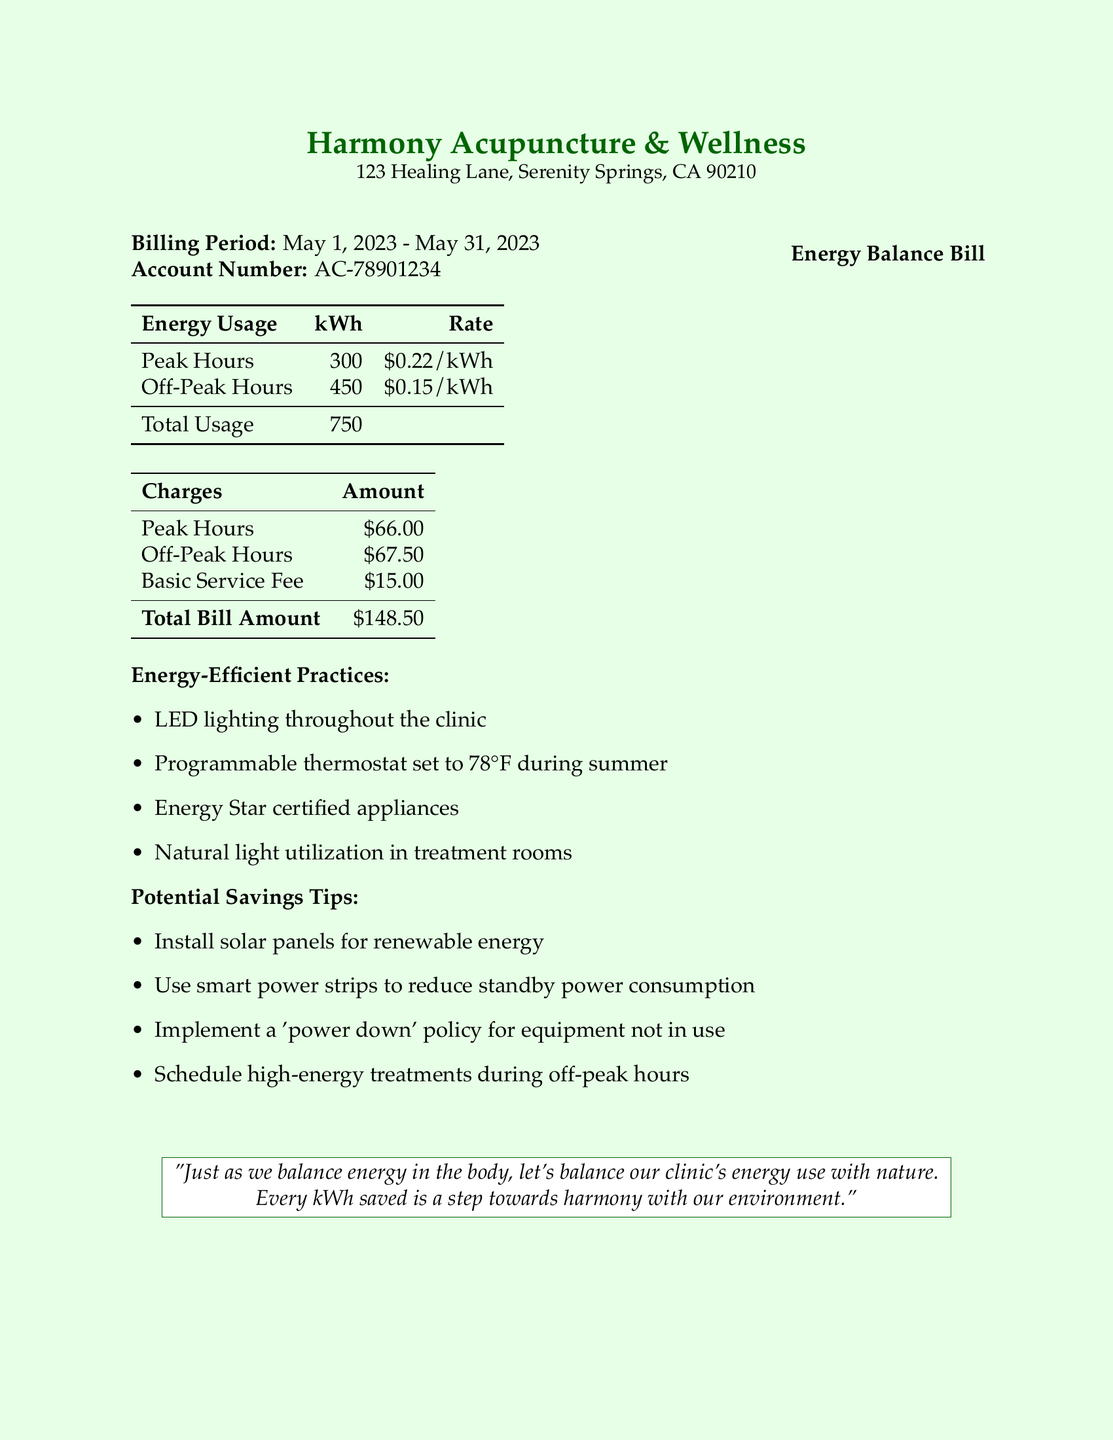What is the billing period? The billing period is specified in the document as the time frame for which the electricity usage is being billed.
Answer: May 1, 2023 - May 31, 2023 What is the total energy usage? The total energy usage is the sum of the peak and off-peak hour usage provided in the table.
Answer: 750 kWh How much was charged for peak hours? The amount charged for peak hours is listed in the charges table.
Answer: $66.00 What is the total bill amount? The total bill amount is calculated by adding all the charges listed in the document.
Answer: $148.50 What energy-efficient practice is mentioned regarding lighting? The document specifies an energy-efficient practice related to lighting used in the clinic.
Answer: LED lighting throughout the clinic What potential savings tip involves renewable energy? Among the potential savings tips, one specifically suggests using a renewable energy source.
Answer: Install solar panels for renewable energy What is the basic service fee? The basic service fee is stated in the charges section of the document.
Answer: $15.00 What temperature is the programmable thermostat set to during summer? The document specifies the temperature setting for the programmable thermostat during the summer months.
Answer: 78°F What is the account number? The account number is a unique identifier for the billing account as listed at the top of the document.
Answer: AC-78901234 